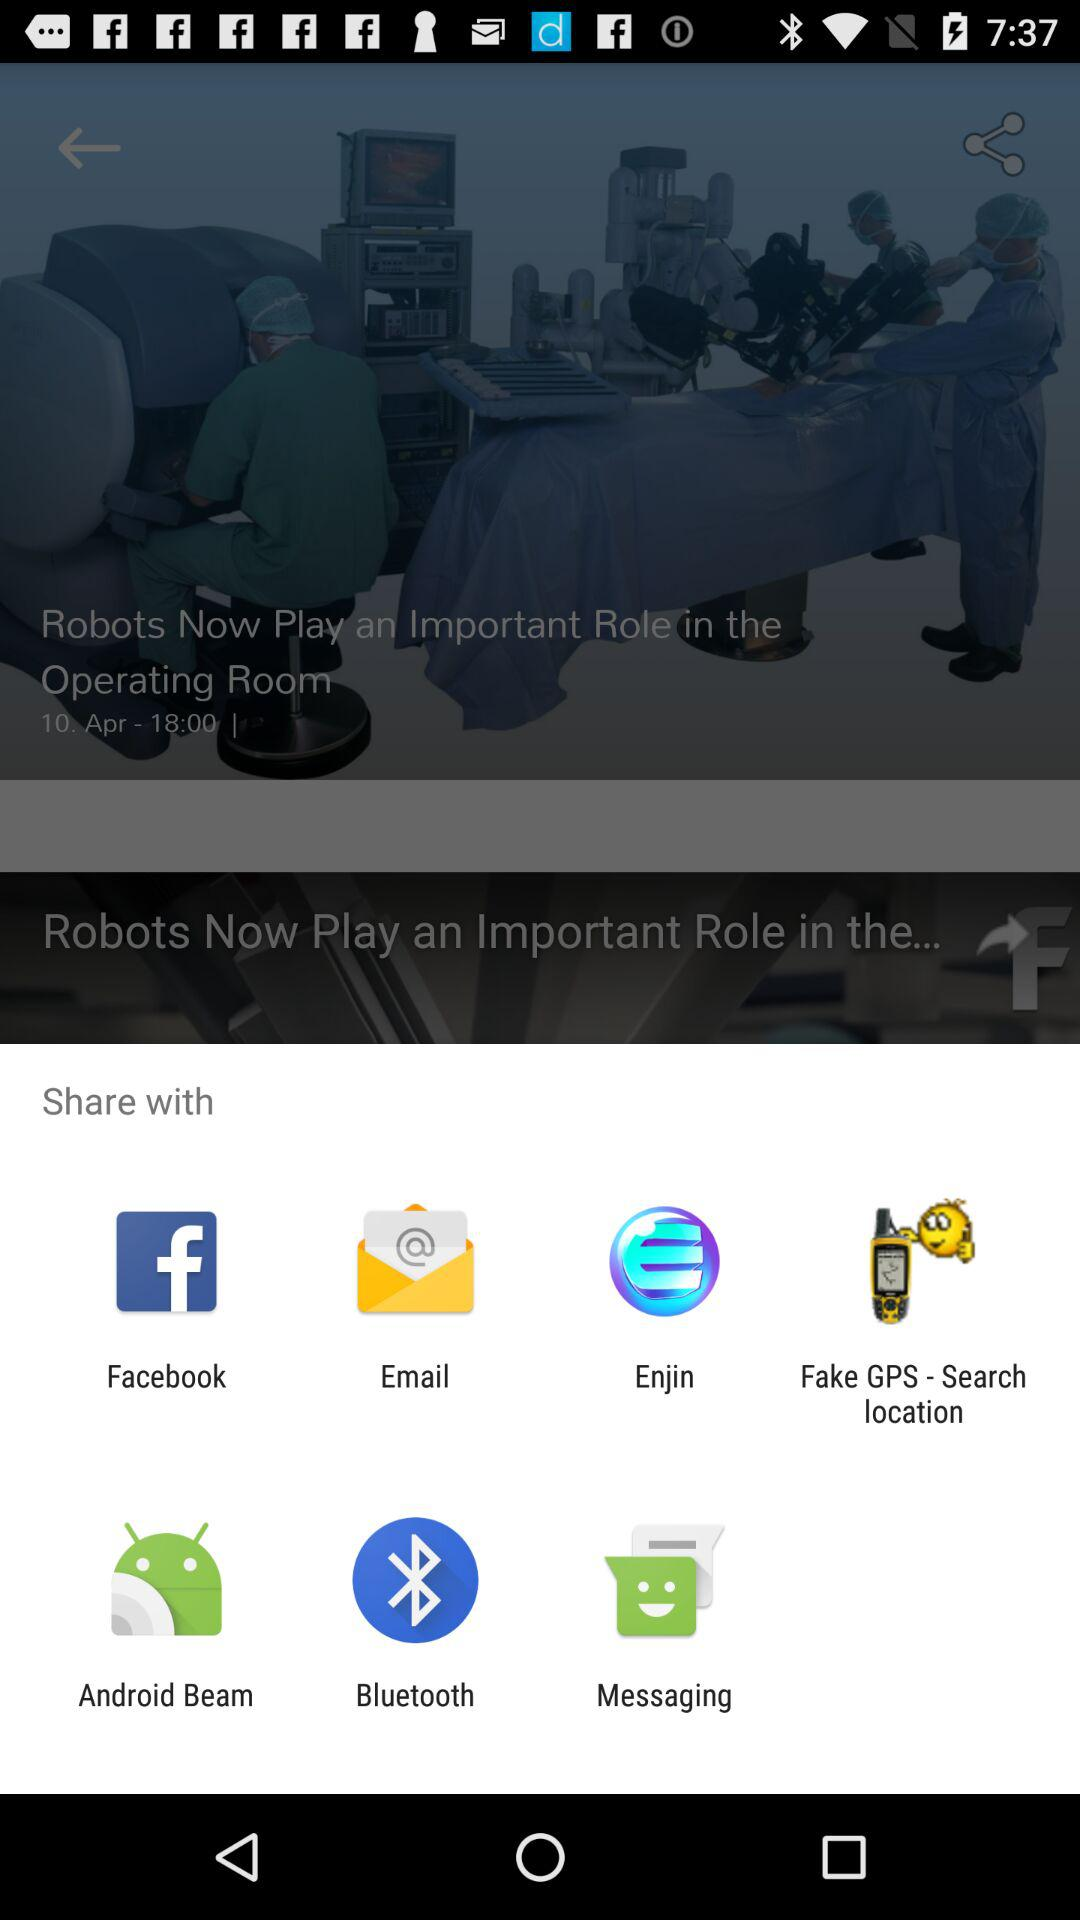Which application can I use to share? You can use "Facebook", "Email", "Enjin", "Fake GPS - Search location", "Android Beam", "Bluetooth" and "Messaging" to share. 